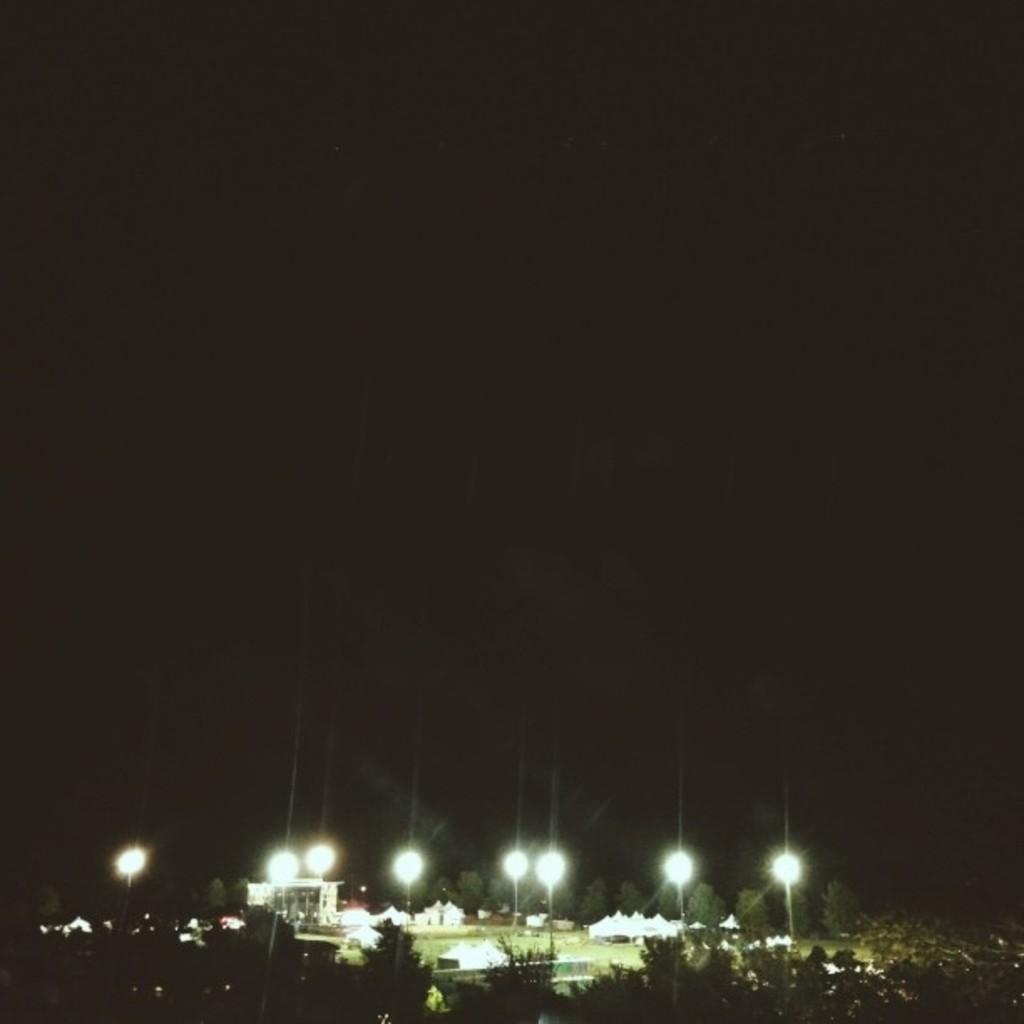What type of vegetation is present at the bottom of the image? There are trees at the bottom of the image. What can be seen illuminated in the image? There are lights visible in the image. What type of structures are present at the bottom of the image? There are buildings at the bottom of the image. What is visible at the top of the image? The sky is visible at the top of the image. What time of day is depicted in the image? The image is set during nighttime. How many bikes are being ridden by people in the image? There are no bikes or people visible in the image. What type of machine is being used for the journey in the image? There is no journey or machine present in the image. 